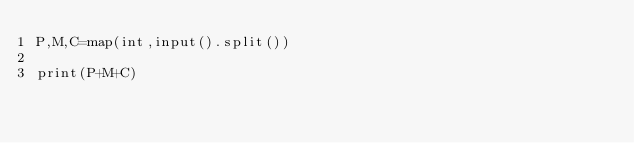Convert code to text. <code><loc_0><loc_0><loc_500><loc_500><_Python_>P,M,C=map(int,input().split())

print(P+M+C)


</code> 